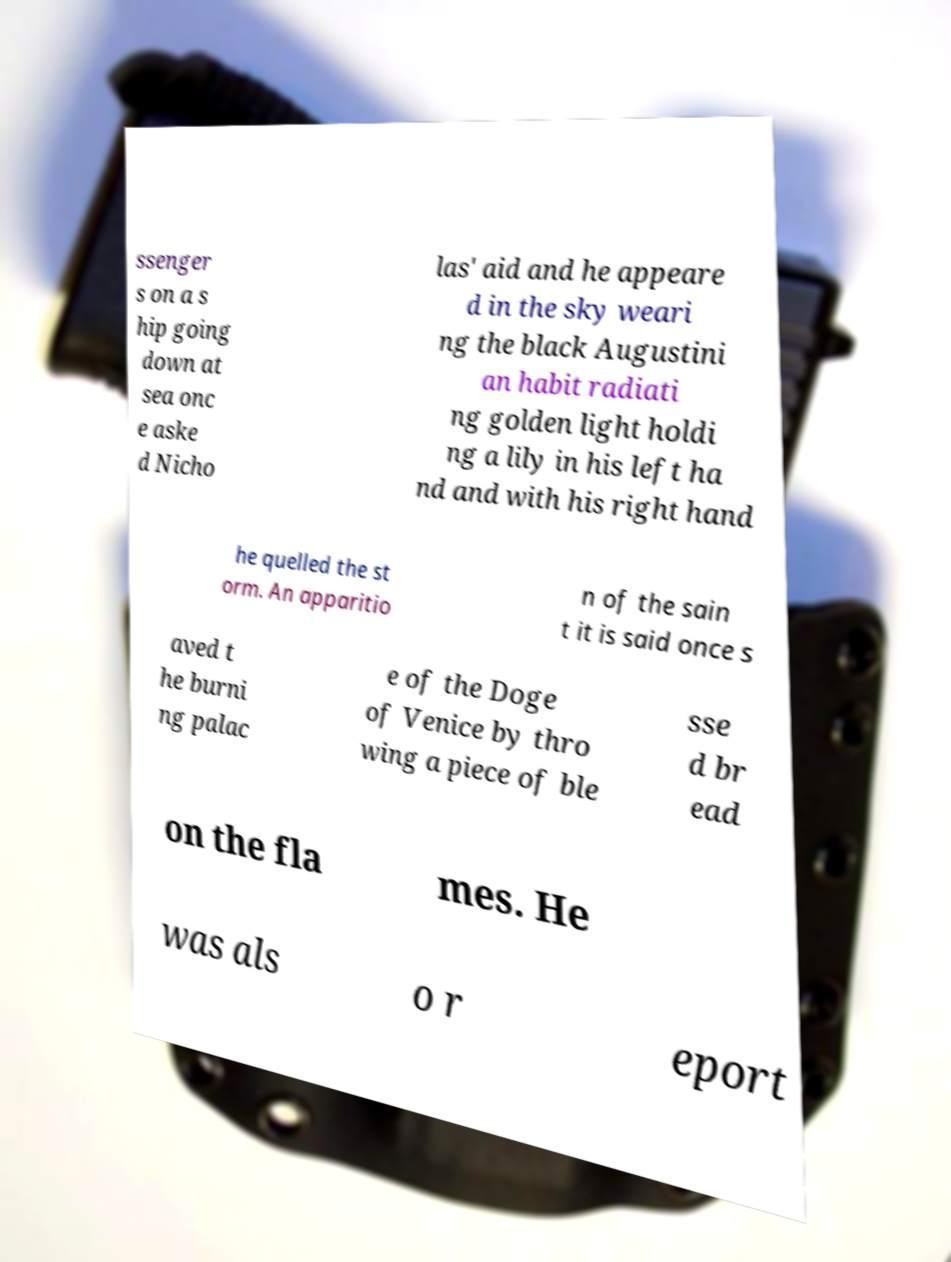Can you accurately transcribe the text from the provided image for me? ssenger s on a s hip going down at sea onc e aske d Nicho las' aid and he appeare d in the sky weari ng the black Augustini an habit radiati ng golden light holdi ng a lily in his left ha nd and with his right hand he quelled the st orm. An apparitio n of the sain t it is said once s aved t he burni ng palac e of the Doge of Venice by thro wing a piece of ble sse d br ead on the fla mes. He was als o r eport 